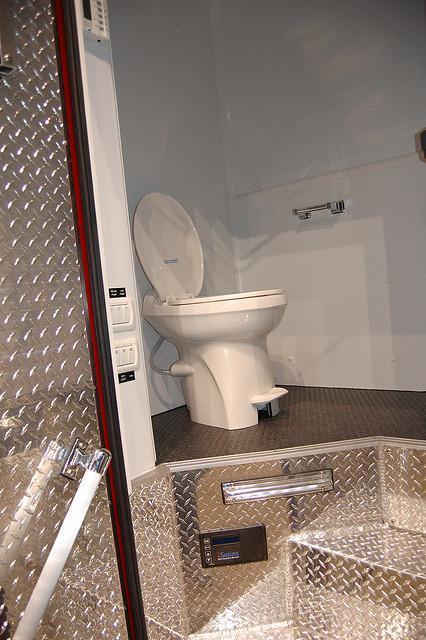How many horses are eating grass?
Give a very brief answer. 0. 